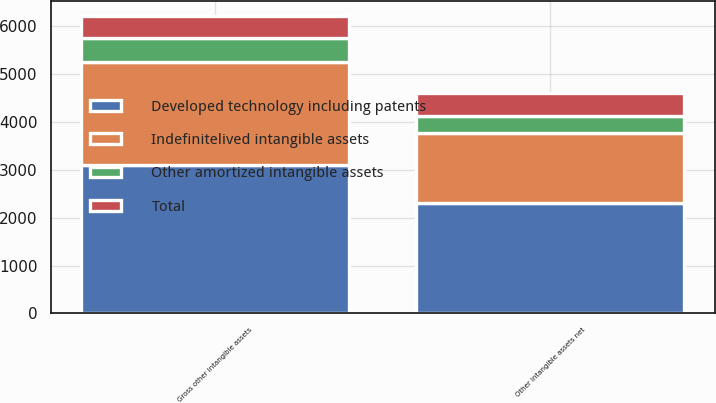Convert chart. <chart><loc_0><loc_0><loc_500><loc_500><stacked_bar_chart><ecel><fcel>Gross other intangible assets<fcel>Other intangible assets net<nl><fcel>Indefinitelived intangible assets<fcel>2144<fcel>1479<nl><fcel>Other amortized intangible assets<fcel>494<fcel>350<nl><fcel>Total<fcel>465<fcel>465<nl><fcel>Developed technology including patents<fcel>3103<fcel>2294<nl></chart> 